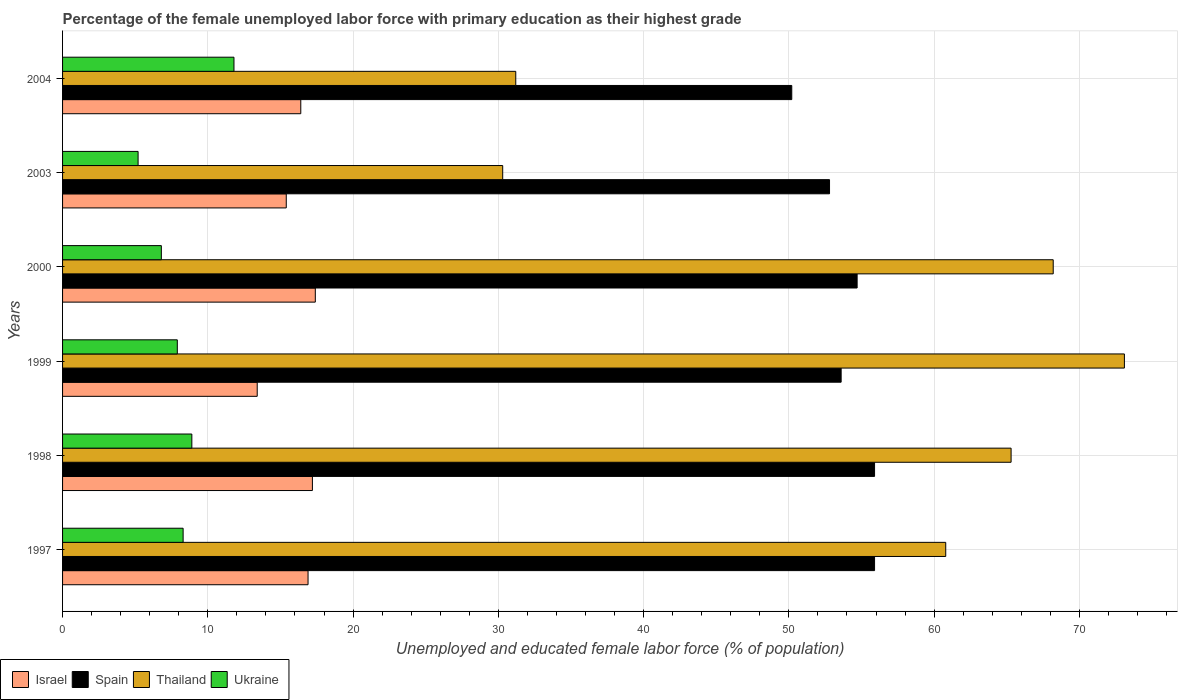How many groups of bars are there?
Offer a terse response. 6. Are the number of bars per tick equal to the number of legend labels?
Provide a short and direct response. Yes. How many bars are there on the 2nd tick from the top?
Make the answer very short. 4. In how many cases, is the number of bars for a given year not equal to the number of legend labels?
Make the answer very short. 0. What is the percentage of the unemployed female labor force with primary education in Israel in 1999?
Your response must be concise. 13.4. Across all years, what is the maximum percentage of the unemployed female labor force with primary education in Thailand?
Make the answer very short. 73.1. Across all years, what is the minimum percentage of the unemployed female labor force with primary education in Thailand?
Offer a very short reply. 30.3. What is the total percentage of the unemployed female labor force with primary education in Thailand in the graph?
Give a very brief answer. 328.9. What is the difference between the percentage of the unemployed female labor force with primary education in Thailand in 1997 and that in 2004?
Your response must be concise. 29.6. What is the difference between the percentage of the unemployed female labor force with primary education in Spain in 2000 and the percentage of the unemployed female labor force with primary education in Ukraine in 1999?
Offer a terse response. 46.8. What is the average percentage of the unemployed female labor force with primary education in Ukraine per year?
Offer a terse response. 8.15. In the year 2003, what is the difference between the percentage of the unemployed female labor force with primary education in Ukraine and percentage of the unemployed female labor force with primary education in Spain?
Provide a short and direct response. -47.6. What is the ratio of the percentage of the unemployed female labor force with primary education in Thailand in 1997 to that in 2000?
Offer a terse response. 0.89. Is the difference between the percentage of the unemployed female labor force with primary education in Ukraine in 1997 and 2004 greater than the difference between the percentage of the unemployed female labor force with primary education in Spain in 1997 and 2004?
Your answer should be very brief. No. What is the difference between the highest and the second highest percentage of the unemployed female labor force with primary education in Israel?
Provide a succinct answer. 0.2. What is the difference between the highest and the lowest percentage of the unemployed female labor force with primary education in Spain?
Ensure brevity in your answer.  5.7. In how many years, is the percentage of the unemployed female labor force with primary education in Spain greater than the average percentage of the unemployed female labor force with primary education in Spain taken over all years?
Ensure brevity in your answer.  3. Is it the case that in every year, the sum of the percentage of the unemployed female labor force with primary education in Spain and percentage of the unemployed female labor force with primary education in Ukraine is greater than the sum of percentage of the unemployed female labor force with primary education in Thailand and percentage of the unemployed female labor force with primary education in Israel?
Your response must be concise. No. Are all the bars in the graph horizontal?
Offer a very short reply. Yes. How many years are there in the graph?
Keep it short and to the point. 6. Does the graph contain grids?
Offer a terse response. Yes. Where does the legend appear in the graph?
Provide a succinct answer. Bottom left. How many legend labels are there?
Offer a terse response. 4. What is the title of the graph?
Offer a very short reply. Percentage of the female unemployed labor force with primary education as their highest grade. What is the label or title of the X-axis?
Offer a very short reply. Unemployed and educated female labor force (% of population). What is the label or title of the Y-axis?
Ensure brevity in your answer.  Years. What is the Unemployed and educated female labor force (% of population) in Israel in 1997?
Give a very brief answer. 16.9. What is the Unemployed and educated female labor force (% of population) of Spain in 1997?
Provide a short and direct response. 55.9. What is the Unemployed and educated female labor force (% of population) in Thailand in 1997?
Provide a short and direct response. 60.8. What is the Unemployed and educated female labor force (% of population) in Ukraine in 1997?
Keep it short and to the point. 8.3. What is the Unemployed and educated female labor force (% of population) in Israel in 1998?
Make the answer very short. 17.2. What is the Unemployed and educated female labor force (% of population) in Spain in 1998?
Make the answer very short. 55.9. What is the Unemployed and educated female labor force (% of population) of Thailand in 1998?
Your answer should be compact. 65.3. What is the Unemployed and educated female labor force (% of population) in Ukraine in 1998?
Your answer should be very brief. 8.9. What is the Unemployed and educated female labor force (% of population) of Israel in 1999?
Your answer should be very brief. 13.4. What is the Unemployed and educated female labor force (% of population) of Spain in 1999?
Offer a very short reply. 53.6. What is the Unemployed and educated female labor force (% of population) of Thailand in 1999?
Your response must be concise. 73.1. What is the Unemployed and educated female labor force (% of population) of Ukraine in 1999?
Make the answer very short. 7.9. What is the Unemployed and educated female labor force (% of population) of Israel in 2000?
Provide a succinct answer. 17.4. What is the Unemployed and educated female labor force (% of population) in Spain in 2000?
Ensure brevity in your answer.  54.7. What is the Unemployed and educated female labor force (% of population) in Thailand in 2000?
Provide a short and direct response. 68.2. What is the Unemployed and educated female labor force (% of population) in Ukraine in 2000?
Provide a short and direct response. 6.8. What is the Unemployed and educated female labor force (% of population) of Israel in 2003?
Provide a succinct answer. 15.4. What is the Unemployed and educated female labor force (% of population) of Spain in 2003?
Ensure brevity in your answer.  52.8. What is the Unemployed and educated female labor force (% of population) of Thailand in 2003?
Your answer should be compact. 30.3. What is the Unemployed and educated female labor force (% of population) of Ukraine in 2003?
Make the answer very short. 5.2. What is the Unemployed and educated female labor force (% of population) in Israel in 2004?
Ensure brevity in your answer.  16.4. What is the Unemployed and educated female labor force (% of population) in Spain in 2004?
Your answer should be compact. 50.2. What is the Unemployed and educated female labor force (% of population) of Thailand in 2004?
Ensure brevity in your answer.  31.2. What is the Unemployed and educated female labor force (% of population) in Ukraine in 2004?
Your answer should be compact. 11.8. Across all years, what is the maximum Unemployed and educated female labor force (% of population) of Israel?
Offer a terse response. 17.4. Across all years, what is the maximum Unemployed and educated female labor force (% of population) in Spain?
Make the answer very short. 55.9. Across all years, what is the maximum Unemployed and educated female labor force (% of population) of Thailand?
Give a very brief answer. 73.1. Across all years, what is the maximum Unemployed and educated female labor force (% of population) of Ukraine?
Ensure brevity in your answer.  11.8. Across all years, what is the minimum Unemployed and educated female labor force (% of population) in Israel?
Ensure brevity in your answer.  13.4. Across all years, what is the minimum Unemployed and educated female labor force (% of population) in Spain?
Keep it short and to the point. 50.2. Across all years, what is the minimum Unemployed and educated female labor force (% of population) of Thailand?
Give a very brief answer. 30.3. Across all years, what is the minimum Unemployed and educated female labor force (% of population) of Ukraine?
Keep it short and to the point. 5.2. What is the total Unemployed and educated female labor force (% of population) of Israel in the graph?
Provide a succinct answer. 96.7. What is the total Unemployed and educated female labor force (% of population) in Spain in the graph?
Provide a short and direct response. 323.1. What is the total Unemployed and educated female labor force (% of population) in Thailand in the graph?
Your answer should be very brief. 328.9. What is the total Unemployed and educated female labor force (% of population) in Ukraine in the graph?
Your answer should be compact. 48.9. What is the difference between the Unemployed and educated female labor force (% of population) in Israel in 1997 and that in 1998?
Make the answer very short. -0.3. What is the difference between the Unemployed and educated female labor force (% of population) of Spain in 1997 and that in 1998?
Offer a terse response. 0. What is the difference between the Unemployed and educated female labor force (% of population) in Thailand in 1997 and that in 1998?
Provide a short and direct response. -4.5. What is the difference between the Unemployed and educated female labor force (% of population) in Israel in 1997 and that in 1999?
Your response must be concise. 3.5. What is the difference between the Unemployed and educated female labor force (% of population) in Thailand in 1997 and that in 1999?
Provide a short and direct response. -12.3. What is the difference between the Unemployed and educated female labor force (% of population) in Ukraine in 1997 and that in 1999?
Make the answer very short. 0.4. What is the difference between the Unemployed and educated female labor force (% of population) of Israel in 1997 and that in 2000?
Provide a short and direct response. -0.5. What is the difference between the Unemployed and educated female labor force (% of population) of Spain in 1997 and that in 2000?
Offer a very short reply. 1.2. What is the difference between the Unemployed and educated female labor force (% of population) of Ukraine in 1997 and that in 2000?
Give a very brief answer. 1.5. What is the difference between the Unemployed and educated female labor force (% of population) in Thailand in 1997 and that in 2003?
Your response must be concise. 30.5. What is the difference between the Unemployed and educated female labor force (% of population) of Ukraine in 1997 and that in 2003?
Offer a very short reply. 3.1. What is the difference between the Unemployed and educated female labor force (% of population) in Spain in 1997 and that in 2004?
Offer a very short reply. 5.7. What is the difference between the Unemployed and educated female labor force (% of population) of Thailand in 1997 and that in 2004?
Make the answer very short. 29.6. What is the difference between the Unemployed and educated female labor force (% of population) of Thailand in 1998 and that in 1999?
Offer a terse response. -7.8. What is the difference between the Unemployed and educated female labor force (% of population) in Ukraine in 1998 and that in 1999?
Offer a very short reply. 1. What is the difference between the Unemployed and educated female labor force (% of population) in Israel in 1998 and that in 2000?
Provide a succinct answer. -0.2. What is the difference between the Unemployed and educated female labor force (% of population) in Spain in 1998 and that in 2000?
Your answer should be very brief. 1.2. What is the difference between the Unemployed and educated female labor force (% of population) of Thailand in 1998 and that in 2000?
Offer a terse response. -2.9. What is the difference between the Unemployed and educated female labor force (% of population) of Ukraine in 1998 and that in 2000?
Your answer should be very brief. 2.1. What is the difference between the Unemployed and educated female labor force (% of population) in Israel in 1998 and that in 2003?
Give a very brief answer. 1.8. What is the difference between the Unemployed and educated female labor force (% of population) of Spain in 1998 and that in 2003?
Your response must be concise. 3.1. What is the difference between the Unemployed and educated female labor force (% of population) of Ukraine in 1998 and that in 2003?
Your answer should be very brief. 3.7. What is the difference between the Unemployed and educated female labor force (% of population) in Thailand in 1998 and that in 2004?
Keep it short and to the point. 34.1. What is the difference between the Unemployed and educated female labor force (% of population) of Ukraine in 1998 and that in 2004?
Offer a terse response. -2.9. What is the difference between the Unemployed and educated female labor force (% of population) of Spain in 1999 and that in 2000?
Ensure brevity in your answer.  -1.1. What is the difference between the Unemployed and educated female labor force (% of population) in Thailand in 1999 and that in 2000?
Your answer should be compact. 4.9. What is the difference between the Unemployed and educated female labor force (% of population) in Ukraine in 1999 and that in 2000?
Your answer should be compact. 1.1. What is the difference between the Unemployed and educated female labor force (% of population) of Israel in 1999 and that in 2003?
Your response must be concise. -2. What is the difference between the Unemployed and educated female labor force (% of population) of Thailand in 1999 and that in 2003?
Make the answer very short. 42.8. What is the difference between the Unemployed and educated female labor force (% of population) in Thailand in 1999 and that in 2004?
Keep it short and to the point. 41.9. What is the difference between the Unemployed and educated female labor force (% of population) of Israel in 2000 and that in 2003?
Offer a very short reply. 2. What is the difference between the Unemployed and educated female labor force (% of population) in Spain in 2000 and that in 2003?
Provide a short and direct response. 1.9. What is the difference between the Unemployed and educated female labor force (% of population) in Thailand in 2000 and that in 2003?
Keep it short and to the point. 37.9. What is the difference between the Unemployed and educated female labor force (% of population) of Ukraine in 2000 and that in 2004?
Your answer should be very brief. -5. What is the difference between the Unemployed and educated female labor force (% of population) in Thailand in 2003 and that in 2004?
Offer a very short reply. -0.9. What is the difference between the Unemployed and educated female labor force (% of population) in Ukraine in 2003 and that in 2004?
Give a very brief answer. -6.6. What is the difference between the Unemployed and educated female labor force (% of population) in Israel in 1997 and the Unemployed and educated female labor force (% of population) in Spain in 1998?
Provide a short and direct response. -39. What is the difference between the Unemployed and educated female labor force (% of population) of Israel in 1997 and the Unemployed and educated female labor force (% of population) of Thailand in 1998?
Your answer should be compact. -48.4. What is the difference between the Unemployed and educated female labor force (% of population) of Israel in 1997 and the Unemployed and educated female labor force (% of population) of Ukraine in 1998?
Your answer should be compact. 8. What is the difference between the Unemployed and educated female labor force (% of population) in Spain in 1997 and the Unemployed and educated female labor force (% of population) in Thailand in 1998?
Ensure brevity in your answer.  -9.4. What is the difference between the Unemployed and educated female labor force (% of population) of Spain in 1997 and the Unemployed and educated female labor force (% of population) of Ukraine in 1998?
Offer a terse response. 47. What is the difference between the Unemployed and educated female labor force (% of population) of Thailand in 1997 and the Unemployed and educated female labor force (% of population) of Ukraine in 1998?
Ensure brevity in your answer.  51.9. What is the difference between the Unemployed and educated female labor force (% of population) in Israel in 1997 and the Unemployed and educated female labor force (% of population) in Spain in 1999?
Ensure brevity in your answer.  -36.7. What is the difference between the Unemployed and educated female labor force (% of population) of Israel in 1997 and the Unemployed and educated female labor force (% of population) of Thailand in 1999?
Your answer should be compact. -56.2. What is the difference between the Unemployed and educated female labor force (% of population) in Israel in 1997 and the Unemployed and educated female labor force (% of population) in Ukraine in 1999?
Provide a short and direct response. 9. What is the difference between the Unemployed and educated female labor force (% of population) in Spain in 1997 and the Unemployed and educated female labor force (% of population) in Thailand in 1999?
Offer a terse response. -17.2. What is the difference between the Unemployed and educated female labor force (% of population) of Spain in 1997 and the Unemployed and educated female labor force (% of population) of Ukraine in 1999?
Your answer should be very brief. 48. What is the difference between the Unemployed and educated female labor force (% of population) of Thailand in 1997 and the Unemployed and educated female labor force (% of population) of Ukraine in 1999?
Provide a succinct answer. 52.9. What is the difference between the Unemployed and educated female labor force (% of population) of Israel in 1997 and the Unemployed and educated female labor force (% of population) of Spain in 2000?
Your response must be concise. -37.8. What is the difference between the Unemployed and educated female labor force (% of population) of Israel in 1997 and the Unemployed and educated female labor force (% of population) of Thailand in 2000?
Offer a terse response. -51.3. What is the difference between the Unemployed and educated female labor force (% of population) in Israel in 1997 and the Unemployed and educated female labor force (% of population) in Ukraine in 2000?
Make the answer very short. 10.1. What is the difference between the Unemployed and educated female labor force (% of population) of Spain in 1997 and the Unemployed and educated female labor force (% of population) of Ukraine in 2000?
Ensure brevity in your answer.  49.1. What is the difference between the Unemployed and educated female labor force (% of population) in Thailand in 1997 and the Unemployed and educated female labor force (% of population) in Ukraine in 2000?
Keep it short and to the point. 54. What is the difference between the Unemployed and educated female labor force (% of population) in Israel in 1997 and the Unemployed and educated female labor force (% of population) in Spain in 2003?
Your answer should be very brief. -35.9. What is the difference between the Unemployed and educated female labor force (% of population) in Spain in 1997 and the Unemployed and educated female labor force (% of population) in Thailand in 2003?
Your answer should be very brief. 25.6. What is the difference between the Unemployed and educated female labor force (% of population) of Spain in 1997 and the Unemployed and educated female labor force (% of population) of Ukraine in 2003?
Provide a succinct answer. 50.7. What is the difference between the Unemployed and educated female labor force (% of population) of Thailand in 1997 and the Unemployed and educated female labor force (% of population) of Ukraine in 2003?
Ensure brevity in your answer.  55.6. What is the difference between the Unemployed and educated female labor force (% of population) of Israel in 1997 and the Unemployed and educated female labor force (% of population) of Spain in 2004?
Offer a very short reply. -33.3. What is the difference between the Unemployed and educated female labor force (% of population) in Israel in 1997 and the Unemployed and educated female labor force (% of population) in Thailand in 2004?
Your answer should be very brief. -14.3. What is the difference between the Unemployed and educated female labor force (% of population) of Spain in 1997 and the Unemployed and educated female labor force (% of population) of Thailand in 2004?
Your answer should be very brief. 24.7. What is the difference between the Unemployed and educated female labor force (% of population) in Spain in 1997 and the Unemployed and educated female labor force (% of population) in Ukraine in 2004?
Provide a succinct answer. 44.1. What is the difference between the Unemployed and educated female labor force (% of population) of Thailand in 1997 and the Unemployed and educated female labor force (% of population) of Ukraine in 2004?
Provide a succinct answer. 49. What is the difference between the Unemployed and educated female labor force (% of population) of Israel in 1998 and the Unemployed and educated female labor force (% of population) of Spain in 1999?
Give a very brief answer. -36.4. What is the difference between the Unemployed and educated female labor force (% of population) in Israel in 1998 and the Unemployed and educated female labor force (% of population) in Thailand in 1999?
Give a very brief answer. -55.9. What is the difference between the Unemployed and educated female labor force (% of population) in Israel in 1998 and the Unemployed and educated female labor force (% of population) in Ukraine in 1999?
Provide a short and direct response. 9.3. What is the difference between the Unemployed and educated female labor force (% of population) in Spain in 1998 and the Unemployed and educated female labor force (% of population) in Thailand in 1999?
Give a very brief answer. -17.2. What is the difference between the Unemployed and educated female labor force (% of population) of Spain in 1998 and the Unemployed and educated female labor force (% of population) of Ukraine in 1999?
Provide a short and direct response. 48. What is the difference between the Unemployed and educated female labor force (% of population) in Thailand in 1998 and the Unemployed and educated female labor force (% of population) in Ukraine in 1999?
Keep it short and to the point. 57.4. What is the difference between the Unemployed and educated female labor force (% of population) in Israel in 1998 and the Unemployed and educated female labor force (% of population) in Spain in 2000?
Offer a terse response. -37.5. What is the difference between the Unemployed and educated female labor force (% of population) of Israel in 1998 and the Unemployed and educated female labor force (% of population) of Thailand in 2000?
Keep it short and to the point. -51. What is the difference between the Unemployed and educated female labor force (% of population) in Spain in 1998 and the Unemployed and educated female labor force (% of population) in Thailand in 2000?
Provide a succinct answer. -12.3. What is the difference between the Unemployed and educated female labor force (% of population) in Spain in 1998 and the Unemployed and educated female labor force (% of population) in Ukraine in 2000?
Provide a succinct answer. 49.1. What is the difference between the Unemployed and educated female labor force (% of population) in Thailand in 1998 and the Unemployed and educated female labor force (% of population) in Ukraine in 2000?
Offer a terse response. 58.5. What is the difference between the Unemployed and educated female labor force (% of population) of Israel in 1998 and the Unemployed and educated female labor force (% of population) of Spain in 2003?
Make the answer very short. -35.6. What is the difference between the Unemployed and educated female labor force (% of population) in Israel in 1998 and the Unemployed and educated female labor force (% of population) in Ukraine in 2003?
Offer a very short reply. 12. What is the difference between the Unemployed and educated female labor force (% of population) of Spain in 1998 and the Unemployed and educated female labor force (% of population) of Thailand in 2003?
Offer a terse response. 25.6. What is the difference between the Unemployed and educated female labor force (% of population) of Spain in 1998 and the Unemployed and educated female labor force (% of population) of Ukraine in 2003?
Keep it short and to the point. 50.7. What is the difference between the Unemployed and educated female labor force (% of population) of Thailand in 1998 and the Unemployed and educated female labor force (% of population) of Ukraine in 2003?
Ensure brevity in your answer.  60.1. What is the difference between the Unemployed and educated female labor force (% of population) of Israel in 1998 and the Unemployed and educated female labor force (% of population) of Spain in 2004?
Offer a terse response. -33. What is the difference between the Unemployed and educated female labor force (% of population) in Israel in 1998 and the Unemployed and educated female labor force (% of population) in Thailand in 2004?
Your answer should be very brief. -14. What is the difference between the Unemployed and educated female labor force (% of population) of Israel in 1998 and the Unemployed and educated female labor force (% of population) of Ukraine in 2004?
Your response must be concise. 5.4. What is the difference between the Unemployed and educated female labor force (% of population) of Spain in 1998 and the Unemployed and educated female labor force (% of population) of Thailand in 2004?
Provide a succinct answer. 24.7. What is the difference between the Unemployed and educated female labor force (% of population) of Spain in 1998 and the Unemployed and educated female labor force (% of population) of Ukraine in 2004?
Offer a very short reply. 44.1. What is the difference between the Unemployed and educated female labor force (% of population) of Thailand in 1998 and the Unemployed and educated female labor force (% of population) of Ukraine in 2004?
Offer a very short reply. 53.5. What is the difference between the Unemployed and educated female labor force (% of population) in Israel in 1999 and the Unemployed and educated female labor force (% of population) in Spain in 2000?
Your answer should be compact. -41.3. What is the difference between the Unemployed and educated female labor force (% of population) of Israel in 1999 and the Unemployed and educated female labor force (% of population) of Thailand in 2000?
Offer a terse response. -54.8. What is the difference between the Unemployed and educated female labor force (% of population) of Spain in 1999 and the Unemployed and educated female labor force (% of population) of Thailand in 2000?
Keep it short and to the point. -14.6. What is the difference between the Unemployed and educated female labor force (% of population) of Spain in 1999 and the Unemployed and educated female labor force (% of population) of Ukraine in 2000?
Your answer should be very brief. 46.8. What is the difference between the Unemployed and educated female labor force (% of population) in Thailand in 1999 and the Unemployed and educated female labor force (% of population) in Ukraine in 2000?
Keep it short and to the point. 66.3. What is the difference between the Unemployed and educated female labor force (% of population) of Israel in 1999 and the Unemployed and educated female labor force (% of population) of Spain in 2003?
Your response must be concise. -39.4. What is the difference between the Unemployed and educated female labor force (% of population) of Israel in 1999 and the Unemployed and educated female labor force (% of population) of Thailand in 2003?
Provide a succinct answer. -16.9. What is the difference between the Unemployed and educated female labor force (% of population) of Spain in 1999 and the Unemployed and educated female labor force (% of population) of Thailand in 2003?
Ensure brevity in your answer.  23.3. What is the difference between the Unemployed and educated female labor force (% of population) of Spain in 1999 and the Unemployed and educated female labor force (% of population) of Ukraine in 2003?
Provide a succinct answer. 48.4. What is the difference between the Unemployed and educated female labor force (% of population) in Thailand in 1999 and the Unemployed and educated female labor force (% of population) in Ukraine in 2003?
Make the answer very short. 67.9. What is the difference between the Unemployed and educated female labor force (% of population) in Israel in 1999 and the Unemployed and educated female labor force (% of population) in Spain in 2004?
Your answer should be very brief. -36.8. What is the difference between the Unemployed and educated female labor force (% of population) in Israel in 1999 and the Unemployed and educated female labor force (% of population) in Thailand in 2004?
Ensure brevity in your answer.  -17.8. What is the difference between the Unemployed and educated female labor force (% of population) of Spain in 1999 and the Unemployed and educated female labor force (% of population) of Thailand in 2004?
Offer a terse response. 22.4. What is the difference between the Unemployed and educated female labor force (% of population) of Spain in 1999 and the Unemployed and educated female labor force (% of population) of Ukraine in 2004?
Provide a short and direct response. 41.8. What is the difference between the Unemployed and educated female labor force (% of population) in Thailand in 1999 and the Unemployed and educated female labor force (% of population) in Ukraine in 2004?
Ensure brevity in your answer.  61.3. What is the difference between the Unemployed and educated female labor force (% of population) in Israel in 2000 and the Unemployed and educated female labor force (% of population) in Spain in 2003?
Your answer should be very brief. -35.4. What is the difference between the Unemployed and educated female labor force (% of population) of Israel in 2000 and the Unemployed and educated female labor force (% of population) of Thailand in 2003?
Your response must be concise. -12.9. What is the difference between the Unemployed and educated female labor force (% of population) in Israel in 2000 and the Unemployed and educated female labor force (% of population) in Ukraine in 2003?
Your response must be concise. 12.2. What is the difference between the Unemployed and educated female labor force (% of population) of Spain in 2000 and the Unemployed and educated female labor force (% of population) of Thailand in 2003?
Provide a succinct answer. 24.4. What is the difference between the Unemployed and educated female labor force (% of population) in Spain in 2000 and the Unemployed and educated female labor force (% of population) in Ukraine in 2003?
Your response must be concise. 49.5. What is the difference between the Unemployed and educated female labor force (% of population) in Thailand in 2000 and the Unemployed and educated female labor force (% of population) in Ukraine in 2003?
Offer a very short reply. 63. What is the difference between the Unemployed and educated female labor force (% of population) of Israel in 2000 and the Unemployed and educated female labor force (% of population) of Spain in 2004?
Offer a terse response. -32.8. What is the difference between the Unemployed and educated female labor force (% of population) in Spain in 2000 and the Unemployed and educated female labor force (% of population) in Thailand in 2004?
Provide a short and direct response. 23.5. What is the difference between the Unemployed and educated female labor force (% of population) in Spain in 2000 and the Unemployed and educated female labor force (% of population) in Ukraine in 2004?
Provide a short and direct response. 42.9. What is the difference between the Unemployed and educated female labor force (% of population) in Thailand in 2000 and the Unemployed and educated female labor force (% of population) in Ukraine in 2004?
Make the answer very short. 56.4. What is the difference between the Unemployed and educated female labor force (% of population) in Israel in 2003 and the Unemployed and educated female labor force (% of population) in Spain in 2004?
Keep it short and to the point. -34.8. What is the difference between the Unemployed and educated female labor force (% of population) of Israel in 2003 and the Unemployed and educated female labor force (% of population) of Thailand in 2004?
Your response must be concise. -15.8. What is the difference between the Unemployed and educated female labor force (% of population) of Spain in 2003 and the Unemployed and educated female labor force (% of population) of Thailand in 2004?
Offer a very short reply. 21.6. What is the difference between the Unemployed and educated female labor force (% of population) of Spain in 2003 and the Unemployed and educated female labor force (% of population) of Ukraine in 2004?
Your answer should be very brief. 41. What is the average Unemployed and educated female labor force (% of population) of Israel per year?
Your answer should be very brief. 16.12. What is the average Unemployed and educated female labor force (% of population) in Spain per year?
Provide a short and direct response. 53.85. What is the average Unemployed and educated female labor force (% of population) in Thailand per year?
Your response must be concise. 54.82. What is the average Unemployed and educated female labor force (% of population) of Ukraine per year?
Make the answer very short. 8.15. In the year 1997, what is the difference between the Unemployed and educated female labor force (% of population) in Israel and Unemployed and educated female labor force (% of population) in Spain?
Make the answer very short. -39. In the year 1997, what is the difference between the Unemployed and educated female labor force (% of population) of Israel and Unemployed and educated female labor force (% of population) of Thailand?
Your answer should be very brief. -43.9. In the year 1997, what is the difference between the Unemployed and educated female labor force (% of population) in Spain and Unemployed and educated female labor force (% of population) in Ukraine?
Your response must be concise. 47.6. In the year 1997, what is the difference between the Unemployed and educated female labor force (% of population) of Thailand and Unemployed and educated female labor force (% of population) of Ukraine?
Give a very brief answer. 52.5. In the year 1998, what is the difference between the Unemployed and educated female labor force (% of population) in Israel and Unemployed and educated female labor force (% of population) in Spain?
Make the answer very short. -38.7. In the year 1998, what is the difference between the Unemployed and educated female labor force (% of population) of Israel and Unemployed and educated female labor force (% of population) of Thailand?
Offer a terse response. -48.1. In the year 1998, what is the difference between the Unemployed and educated female labor force (% of population) of Israel and Unemployed and educated female labor force (% of population) of Ukraine?
Offer a terse response. 8.3. In the year 1998, what is the difference between the Unemployed and educated female labor force (% of population) in Spain and Unemployed and educated female labor force (% of population) in Thailand?
Your response must be concise. -9.4. In the year 1998, what is the difference between the Unemployed and educated female labor force (% of population) in Spain and Unemployed and educated female labor force (% of population) in Ukraine?
Ensure brevity in your answer.  47. In the year 1998, what is the difference between the Unemployed and educated female labor force (% of population) in Thailand and Unemployed and educated female labor force (% of population) in Ukraine?
Provide a succinct answer. 56.4. In the year 1999, what is the difference between the Unemployed and educated female labor force (% of population) in Israel and Unemployed and educated female labor force (% of population) in Spain?
Offer a terse response. -40.2. In the year 1999, what is the difference between the Unemployed and educated female labor force (% of population) of Israel and Unemployed and educated female labor force (% of population) of Thailand?
Keep it short and to the point. -59.7. In the year 1999, what is the difference between the Unemployed and educated female labor force (% of population) of Israel and Unemployed and educated female labor force (% of population) of Ukraine?
Offer a terse response. 5.5. In the year 1999, what is the difference between the Unemployed and educated female labor force (% of population) of Spain and Unemployed and educated female labor force (% of population) of Thailand?
Your answer should be compact. -19.5. In the year 1999, what is the difference between the Unemployed and educated female labor force (% of population) of Spain and Unemployed and educated female labor force (% of population) of Ukraine?
Provide a succinct answer. 45.7. In the year 1999, what is the difference between the Unemployed and educated female labor force (% of population) in Thailand and Unemployed and educated female labor force (% of population) in Ukraine?
Your answer should be very brief. 65.2. In the year 2000, what is the difference between the Unemployed and educated female labor force (% of population) of Israel and Unemployed and educated female labor force (% of population) of Spain?
Offer a very short reply. -37.3. In the year 2000, what is the difference between the Unemployed and educated female labor force (% of population) in Israel and Unemployed and educated female labor force (% of population) in Thailand?
Provide a succinct answer. -50.8. In the year 2000, what is the difference between the Unemployed and educated female labor force (% of population) of Israel and Unemployed and educated female labor force (% of population) of Ukraine?
Keep it short and to the point. 10.6. In the year 2000, what is the difference between the Unemployed and educated female labor force (% of population) in Spain and Unemployed and educated female labor force (% of population) in Ukraine?
Ensure brevity in your answer.  47.9. In the year 2000, what is the difference between the Unemployed and educated female labor force (% of population) in Thailand and Unemployed and educated female labor force (% of population) in Ukraine?
Ensure brevity in your answer.  61.4. In the year 2003, what is the difference between the Unemployed and educated female labor force (% of population) in Israel and Unemployed and educated female labor force (% of population) in Spain?
Ensure brevity in your answer.  -37.4. In the year 2003, what is the difference between the Unemployed and educated female labor force (% of population) in Israel and Unemployed and educated female labor force (% of population) in Thailand?
Make the answer very short. -14.9. In the year 2003, what is the difference between the Unemployed and educated female labor force (% of population) in Spain and Unemployed and educated female labor force (% of population) in Thailand?
Provide a succinct answer. 22.5. In the year 2003, what is the difference between the Unemployed and educated female labor force (% of population) of Spain and Unemployed and educated female labor force (% of population) of Ukraine?
Offer a very short reply. 47.6. In the year 2003, what is the difference between the Unemployed and educated female labor force (% of population) in Thailand and Unemployed and educated female labor force (% of population) in Ukraine?
Your answer should be very brief. 25.1. In the year 2004, what is the difference between the Unemployed and educated female labor force (% of population) of Israel and Unemployed and educated female labor force (% of population) of Spain?
Offer a very short reply. -33.8. In the year 2004, what is the difference between the Unemployed and educated female labor force (% of population) of Israel and Unemployed and educated female labor force (% of population) of Thailand?
Provide a short and direct response. -14.8. In the year 2004, what is the difference between the Unemployed and educated female labor force (% of population) of Israel and Unemployed and educated female labor force (% of population) of Ukraine?
Provide a succinct answer. 4.6. In the year 2004, what is the difference between the Unemployed and educated female labor force (% of population) of Spain and Unemployed and educated female labor force (% of population) of Thailand?
Keep it short and to the point. 19. In the year 2004, what is the difference between the Unemployed and educated female labor force (% of population) of Spain and Unemployed and educated female labor force (% of population) of Ukraine?
Make the answer very short. 38.4. What is the ratio of the Unemployed and educated female labor force (% of population) in Israel in 1997 to that in 1998?
Your answer should be compact. 0.98. What is the ratio of the Unemployed and educated female labor force (% of population) in Spain in 1997 to that in 1998?
Your answer should be very brief. 1. What is the ratio of the Unemployed and educated female labor force (% of population) of Thailand in 1997 to that in 1998?
Give a very brief answer. 0.93. What is the ratio of the Unemployed and educated female labor force (% of population) of Ukraine in 1997 to that in 1998?
Provide a short and direct response. 0.93. What is the ratio of the Unemployed and educated female labor force (% of population) in Israel in 1997 to that in 1999?
Give a very brief answer. 1.26. What is the ratio of the Unemployed and educated female labor force (% of population) in Spain in 1997 to that in 1999?
Your response must be concise. 1.04. What is the ratio of the Unemployed and educated female labor force (% of population) in Thailand in 1997 to that in 1999?
Offer a very short reply. 0.83. What is the ratio of the Unemployed and educated female labor force (% of population) of Ukraine in 1997 to that in 1999?
Your response must be concise. 1.05. What is the ratio of the Unemployed and educated female labor force (% of population) in Israel in 1997 to that in 2000?
Keep it short and to the point. 0.97. What is the ratio of the Unemployed and educated female labor force (% of population) in Spain in 1997 to that in 2000?
Offer a very short reply. 1.02. What is the ratio of the Unemployed and educated female labor force (% of population) in Thailand in 1997 to that in 2000?
Offer a very short reply. 0.89. What is the ratio of the Unemployed and educated female labor force (% of population) of Ukraine in 1997 to that in 2000?
Offer a very short reply. 1.22. What is the ratio of the Unemployed and educated female labor force (% of population) of Israel in 1997 to that in 2003?
Offer a very short reply. 1.1. What is the ratio of the Unemployed and educated female labor force (% of population) of Spain in 1997 to that in 2003?
Your answer should be compact. 1.06. What is the ratio of the Unemployed and educated female labor force (% of population) in Thailand in 1997 to that in 2003?
Ensure brevity in your answer.  2.01. What is the ratio of the Unemployed and educated female labor force (% of population) in Ukraine in 1997 to that in 2003?
Give a very brief answer. 1.6. What is the ratio of the Unemployed and educated female labor force (% of population) in Israel in 1997 to that in 2004?
Provide a short and direct response. 1.03. What is the ratio of the Unemployed and educated female labor force (% of population) of Spain in 1997 to that in 2004?
Keep it short and to the point. 1.11. What is the ratio of the Unemployed and educated female labor force (% of population) of Thailand in 1997 to that in 2004?
Provide a succinct answer. 1.95. What is the ratio of the Unemployed and educated female labor force (% of population) of Ukraine in 1997 to that in 2004?
Offer a very short reply. 0.7. What is the ratio of the Unemployed and educated female labor force (% of population) of Israel in 1998 to that in 1999?
Give a very brief answer. 1.28. What is the ratio of the Unemployed and educated female labor force (% of population) in Spain in 1998 to that in 1999?
Keep it short and to the point. 1.04. What is the ratio of the Unemployed and educated female labor force (% of population) in Thailand in 1998 to that in 1999?
Give a very brief answer. 0.89. What is the ratio of the Unemployed and educated female labor force (% of population) in Ukraine in 1998 to that in 1999?
Provide a succinct answer. 1.13. What is the ratio of the Unemployed and educated female labor force (% of population) in Israel in 1998 to that in 2000?
Ensure brevity in your answer.  0.99. What is the ratio of the Unemployed and educated female labor force (% of population) of Spain in 1998 to that in 2000?
Ensure brevity in your answer.  1.02. What is the ratio of the Unemployed and educated female labor force (% of population) in Thailand in 1998 to that in 2000?
Offer a terse response. 0.96. What is the ratio of the Unemployed and educated female labor force (% of population) in Ukraine in 1998 to that in 2000?
Your answer should be very brief. 1.31. What is the ratio of the Unemployed and educated female labor force (% of population) of Israel in 1998 to that in 2003?
Make the answer very short. 1.12. What is the ratio of the Unemployed and educated female labor force (% of population) in Spain in 1998 to that in 2003?
Your answer should be very brief. 1.06. What is the ratio of the Unemployed and educated female labor force (% of population) of Thailand in 1998 to that in 2003?
Your answer should be compact. 2.16. What is the ratio of the Unemployed and educated female labor force (% of population) of Ukraine in 1998 to that in 2003?
Your answer should be compact. 1.71. What is the ratio of the Unemployed and educated female labor force (% of population) of Israel in 1998 to that in 2004?
Offer a terse response. 1.05. What is the ratio of the Unemployed and educated female labor force (% of population) in Spain in 1998 to that in 2004?
Offer a very short reply. 1.11. What is the ratio of the Unemployed and educated female labor force (% of population) of Thailand in 1998 to that in 2004?
Offer a terse response. 2.09. What is the ratio of the Unemployed and educated female labor force (% of population) in Ukraine in 1998 to that in 2004?
Offer a very short reply. 0.75. What is the ratio of the Unemployed and educated female labor force (% of population) in Israel in 1999 to that in 2000?
Your response must be concise. 0.77. What is the ratio of the Unemployed and educated female labor force (% of population) of Spain in 1999 to that in 2000?
Provide a short and direct response. 0.98. What is the ratio of the Unemployed and educated female labor force (% of population) of Thailand in 1999 to that in 2000?
Ensure brevity in your answer.  1.07. What is the ratio of the Unemployed and educated female labor force (% of population) of Ukraine in 1999 to that in 2000?
Your answer should be very brief. 1.16. What is the ratio of the Unemployed and educated female labor force (% of population) of Israel in 1999 to that in 2003?
Keep it short and to the point. 0.87. What is the ratio of the Unemployed and educated female labor force (% of population) in Spain in 1999 to that in 2003?
Ensure brevity in your answer.  1.02. What is the ratio of the Unemployed and educated female labor force (% of population) of Thailand in 1999 to that in 2003?
Offer a very short reply. 2.41. What is the ratio of the Unemployed and educated female labor force (% of population) in Ukraine in 1999 to that in 2003?
Make the answer very short. 1.52. What is the ratio of the Unemployed and educated female labor force (% of population) of Israel in 1999 to that in 2004?
Provide a short and direct response. 0.82. What is the ratio of the Unemployed and educated female labor force (% of population) of Spain in 1999 to that in 2004?
Your response must be concise. 1.07. What is the ratio of the Unemployed and educated female labor force (% of population) of Thailand in 1999 to that in 2004?
Offer a terse response. 2.34. What is the ratio of the Unemployed and educated female labor force (% of population) of Ukraine in 1999 to that in 2004?
Provide a short and direct response. 0.67. What is the ratio of the Unemployed and educated female labor force (% of population) of Israel in 2000 to that in 2003?
Offer a very short reply. 1.13. What is the ratio of the Unemployed and educated female labor force (% of population) in Spain in 2000 to that in 2003?
Offer a very short reply. 1.04. What is the ratio of the Unemployed and educated female labor force (% of population) in Thailand in 2000 to that in 2003?
Your answer should be compact. 2.25. What is the ratio of the Unemployed and educated female labor force (% of population) in Ukraine in 2000 to that in 2003?
Ensure brevity in your answer.  1.31. What is the ratio of the Unemployed and educated female labor force (% of population) of Israel in 2000 to that in 2004?
Keep it short and to the point. 1.06. What is the ratio of the Unemployed and educated female labor force (% of population) in Spain in 2000 to that in 2004?
Make the answer very short. 1.09. What is the ratio of the Unemployed and educated female labor force (% of population) of Thailand in 2000 to that in 2004?
Your response must be concise. 2.19. What is the ratio of the Unemployed and educated female labor force (% of population) of Ukraine in 2000 to that in 2004?
Provide a succinct answer. 0.58. What is the ratio of the Unemployed and educated female labor force (% of population) of Israel in 2003 to that in 2004?
Provide a succinct answer. 0.94. What is the ratio of the Unemployed and educated female labor force (% of population) in Spain in 2003 to that in 2004?
Provide a short and direct response. 1.05. What is the ratio of the Unemployed and educated female labor force (% of population) of Thailand in 2003 to that in 2004?
Your answer should be very brief. 0.97. What is the ratio of the Unemployed and educated female labor force (% of population) in Ukraine in 2003 to that in 2004?
Make the answer very short. 0.44. What is the difference between the highest and the second highest Unemployed and educated female labor force (% of population) in Spain?
Provide a succinct answer. 0. What is the difference between the highest and the second highest Unemployed and educated female labor force (% of population) of Thailand?
Your answer should be very brief. 4.9. What is the difference between the highest and the second highest Unemployed and educated female labor force (% of population) in Ukraine?
Make the answer very short. 2.9. What is the difference between the highest and the lowest Unemployed and educated female labor force (% of population) in Israel?
Offer a very short reply. 4. What is the difference between the highest and the lowest Unemployed and educated female labor force (% of population) of Spain?
Your answer should be compact. 5.7. What is the difference between the highest and the lowest Unemployed and educated female labor force (% of population) in Thailand?
Make the answer very short. 42.8. What is the difference between the highest and the lowest Unemployed and educated female labor force (% of population) in Ukraine?
Ensure brevity in your answer.  6.6. 